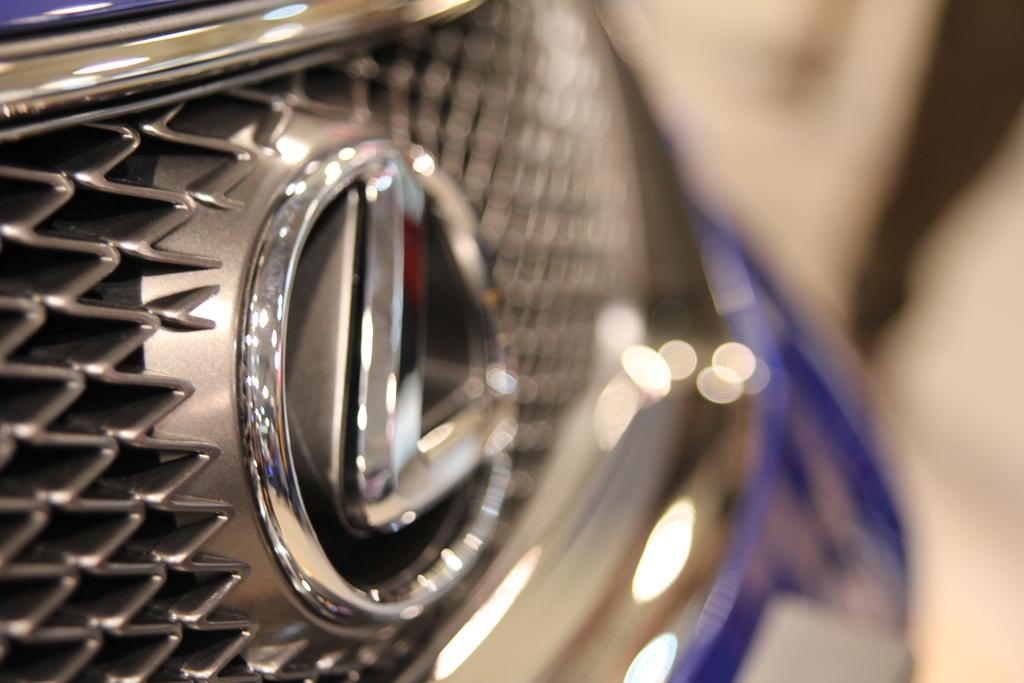What is the main subject of the image? There is a vehicle in the image. Can you describe the part of the vehicle that is visible? The front part of the vehicle is visible in the foreground. How many sisters are sitting on the yoke in the image? There are no sisters or yoke present in the image; it features a vehicle with the front part visible. 